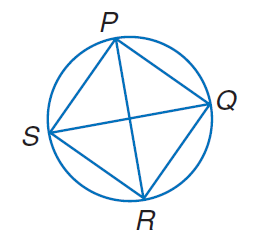Answer the mathemtical geometry problem and directly provide the correct option letter.
Question: P Q R S is a rhombus inscribed in a circle. Find m \angle Q R P.
Choices: A: 30 B: 45 C: 60 D: 90 B 